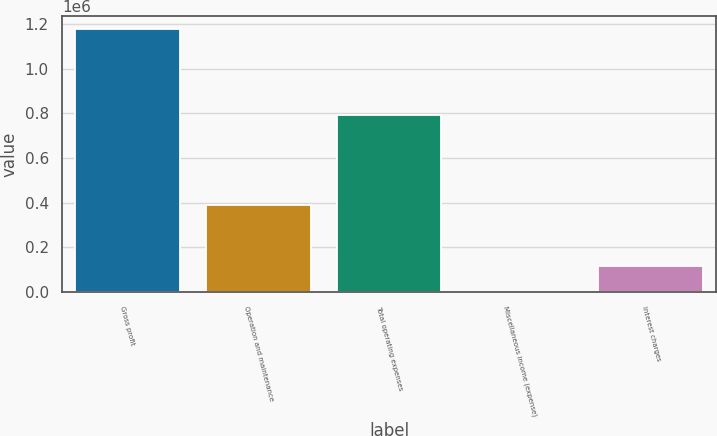Convert chart. <chart><loc_0><loc_0><loc_500><loc_500><bar_chart><fcel>Gross profit<fcel>Operation and maintenance<fcel>Total operating expenses<fcel>Miscellaneous income (expense)<fcel>Interest charges<nl><fcel>1.17652e+06<fcel>387228<fcel>791947<fcel>381<fcel>117994<nl></chart> 